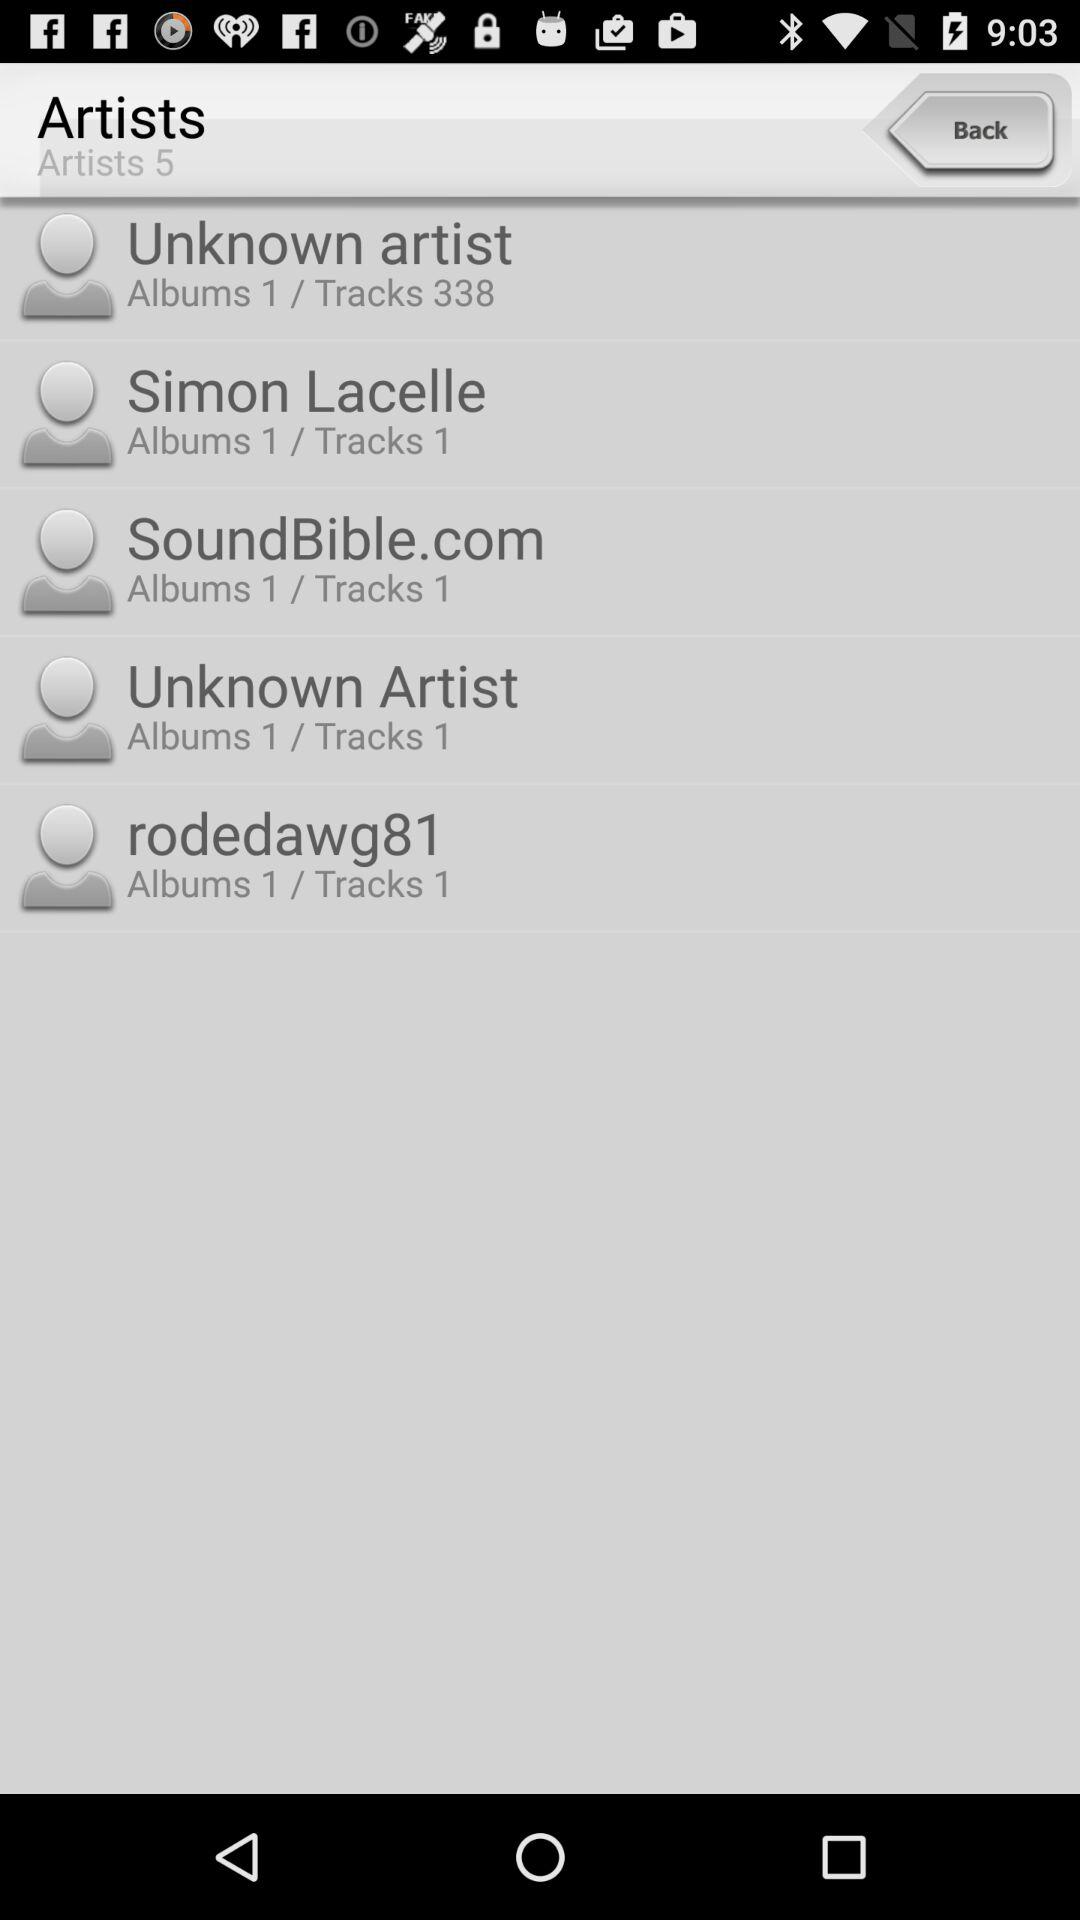How many tracks does "SoundBible.com" have? "SoundBible.com" has 1 track. 